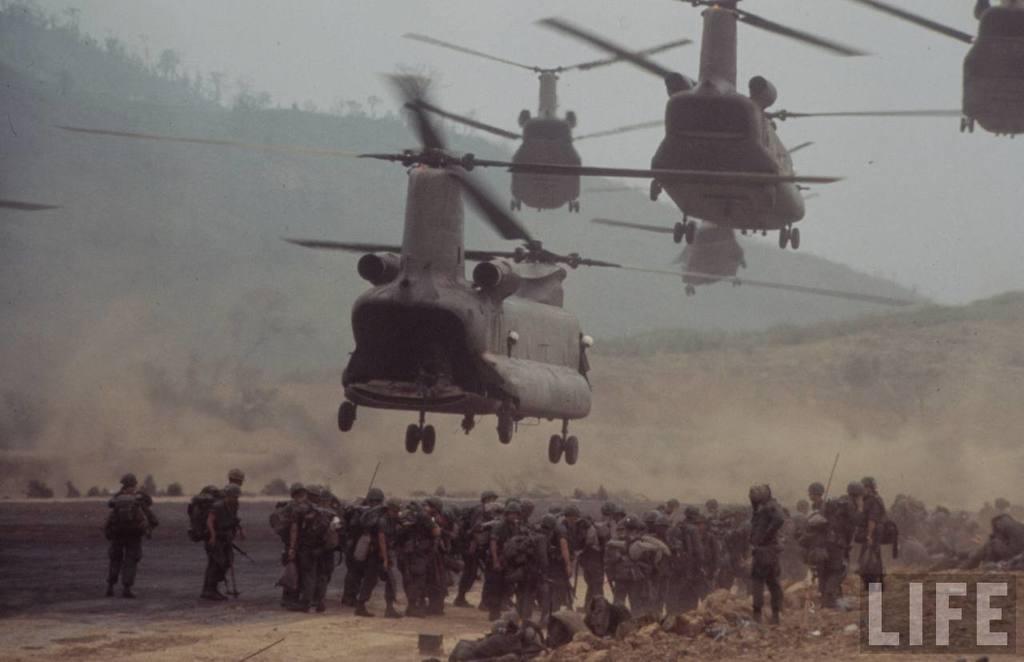Can you describe this image briefly? In this image there are so many military officers standing on the ground by wearing the bags and holding the guns. At the top there are so many helicopters. In the background there are hills on which there are trees. At the top there is the sky. At the bottom there is ground on which there are stones. 